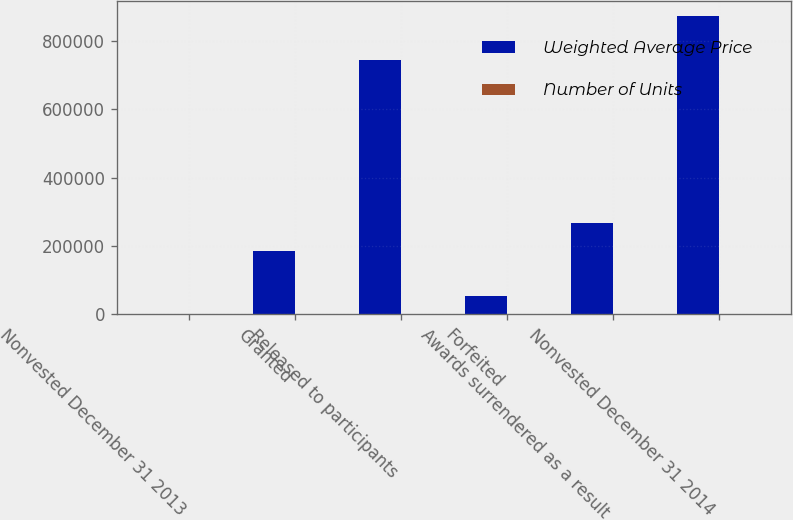Convert chart. <chart><loc_0><loc_0><loc_500><loc_500><stacked_bar_chart><ecel><fcel>Nonvested December 31 2013<fcel>Granted<fcel>Released to participants<fcel>Forfeited<fcel>Awards surrendered as a result<fcel>Nonvested December 31 2014<nl><fcel>Weighted Average Price<fcel>64.75<fcel>186436<fcel>743897<fcel>53927<fcel>265750<fcel>872730<nl><fcel>Number of Units<fcel>41.1<fcel>64.75<fcel>34.68<fcel>48.99<fcel>47.62<fcel>44.55<nl></chart> 